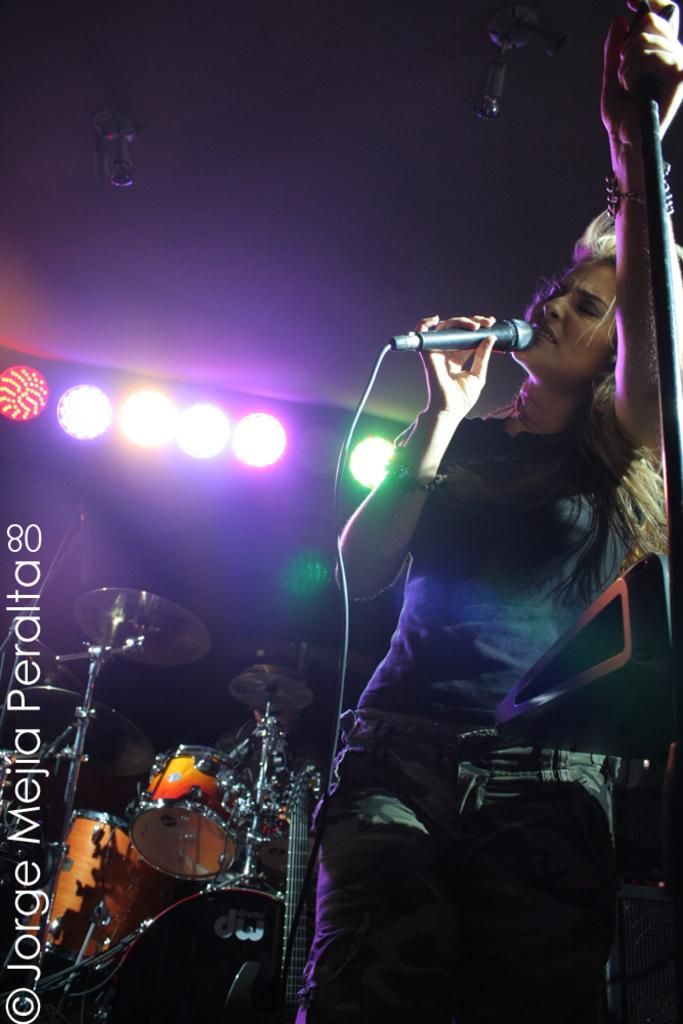What is the woman in the image doing? The woman is singing in the image. What is she holding while singing? She is holding a microphone. What is she wearing? She is wearing a black t-shirt and pants. What other instruments can be seen in the image? There are drums visible in the image. What can be seen illuminating the scene? There are lights visible in the image. What is the woman holding in her other hand? She is holding a stick in her hands. What type of chalk is the woman using to draw on the wall in the image? There is no chalk or drawing on the wall present in the image. 